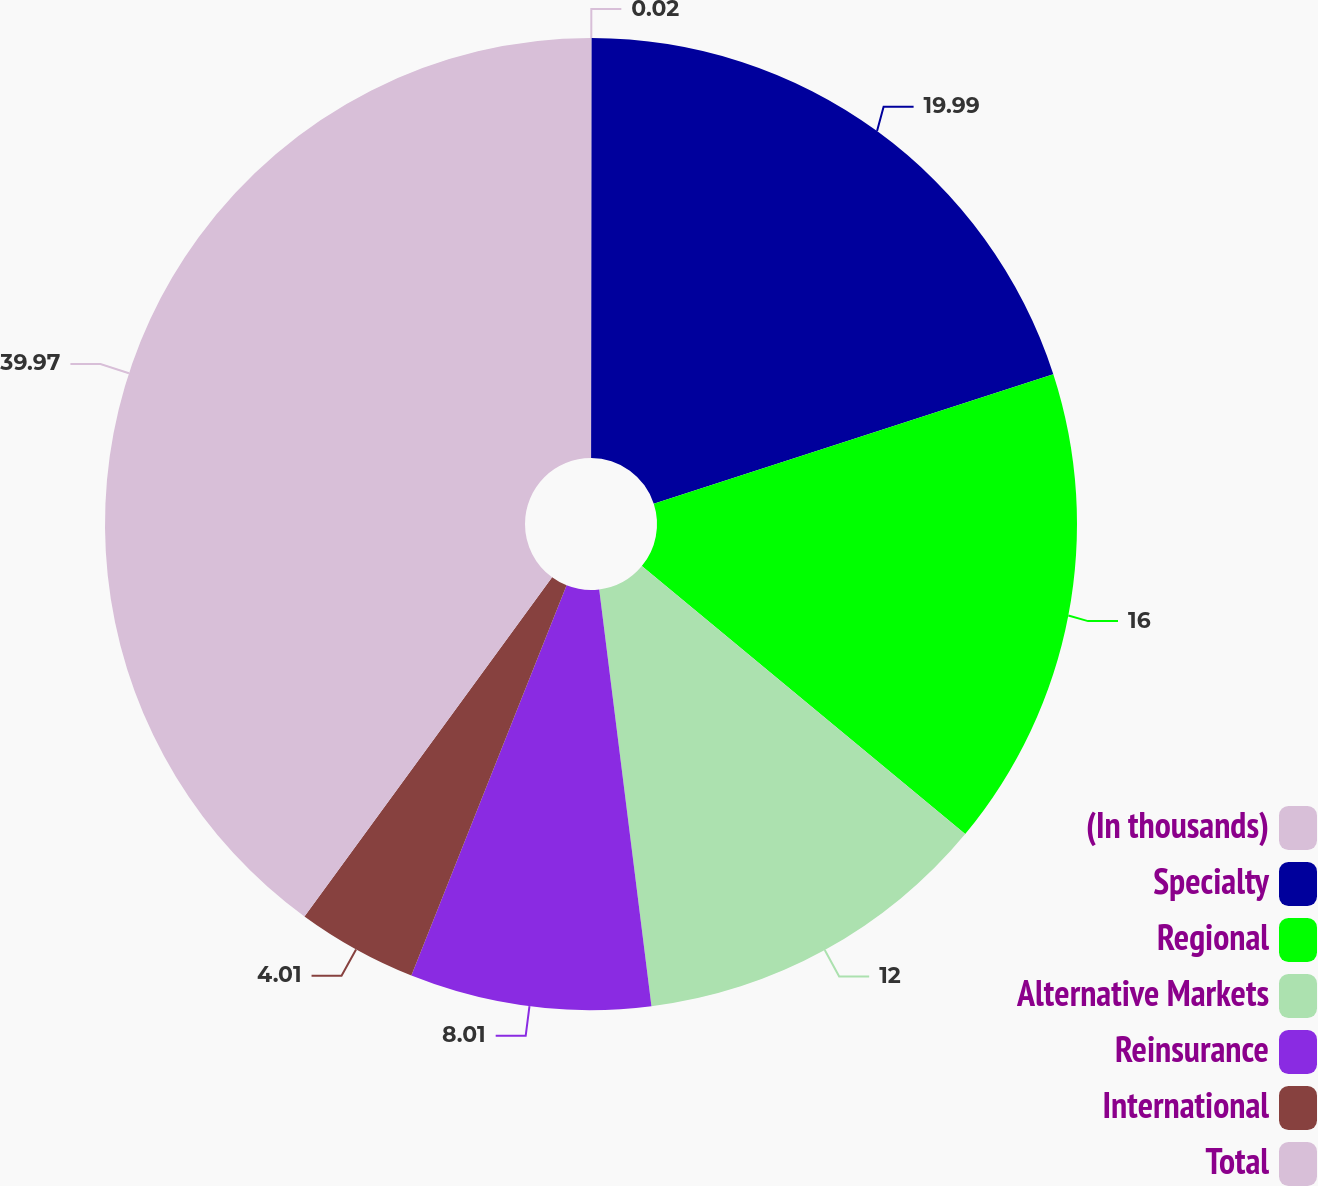Convert chart. <chart><loc_0><loc_0><loc_500><loc_500><pie_chart><fcel>(In thousands)<fcel>Specialty<fcel>Regional<fcel>Alternative Markets<fcel>Reinsurance<fcel>International<fcel>Total<nl><fcel>0.02%<fcel>19.99%<fcel>16.0%<fcel>12.0%<fcel>8.01%<fcel>4.01%<fcel>39.96%<nl></chart> 